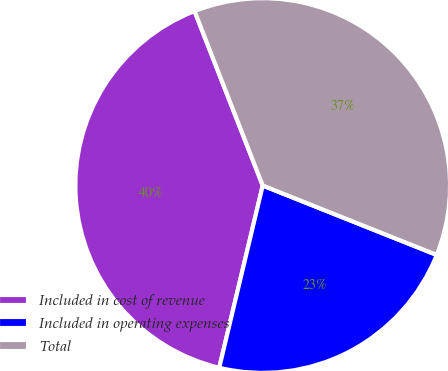Convert chart to OTSL. <chart><loc_0><loc_0><loc_500><loc_500><pie_chart><fcel>Included in cost of revenue<fcel>Included in operating expenses<fcel>Total<nl><fcel>40.34%<fcel>22.69%<fcel>36.97%<nl></chart> 